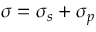<formula> <loc_0><loc_0><loc_500><loc_500>\sigma = \sigma _ { s } + \sigma _ { p }</formula> 